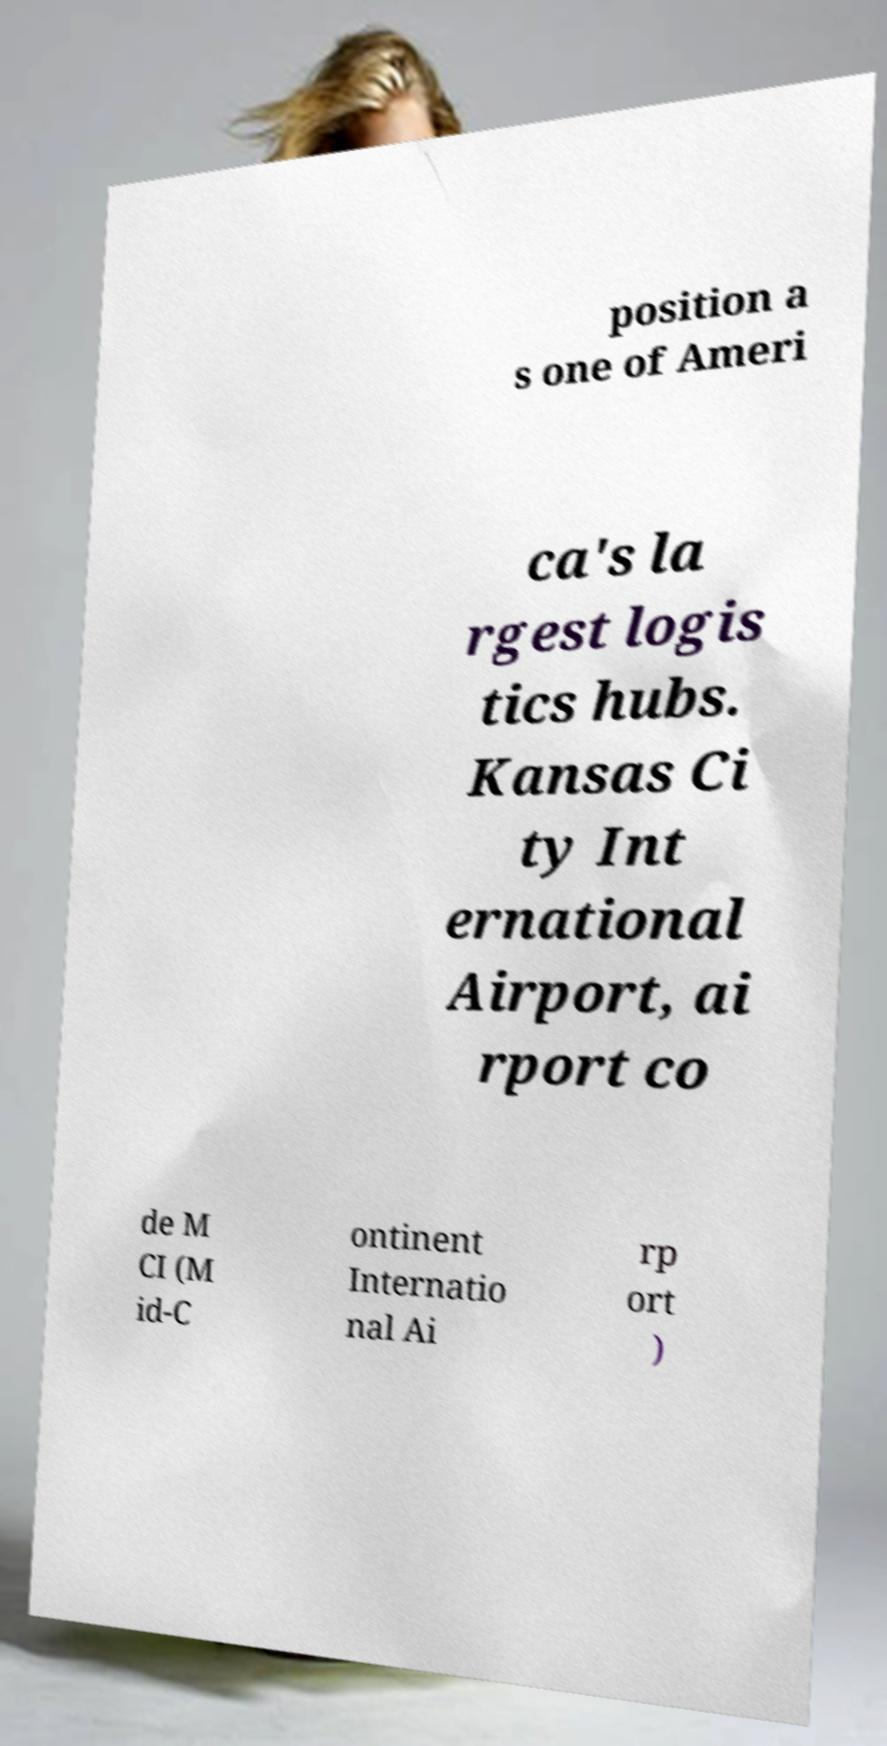Please read and relay the text visible in this image. What does it say? position a s one of Ameri ca's la rgest logis tics hubs. Kansas Ci ty Int ernational Airport, ai rport co de M CI (M id-C ontinent Internatio nal Ai rp ort ) 